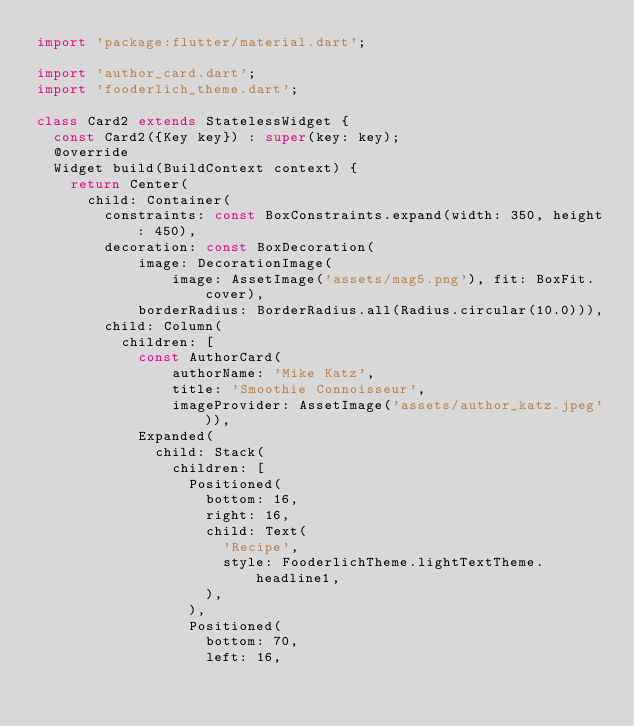<code> <loc_0><loc_0><loc_500><loc_500><_Dart_>import 'package:flutter/material.dart';

import 'author_card.dart';
import 'fooderlich_theme.dart';

class Card2 extends StatelessWidget {
  const Card2({Key key}) : super(key: key);
  @override
  Widget build(BuildContext context) {
    return Center(
      child: Container(
        constraints: const BoxConstraints.expand(width: 350, height: 450),
        decoration: const BoxDecoration(
            image: DecorationImage(
                image: AssetImage('assets/mag5.png'), fit: BoxFit.cover),
            borderRadius: BorderRadius.all(Radius.circular(10.0))),
        child: Column(
          children: [
            const AuthorCard(
                authorName: 'Mike Katz',
                title: 'Smoothie Connoisseur',
                imageProvider: AssetImage('assets/author_katz.jpeg')),
            Expanded(
              child: Stack(
                children: [
                  Positioned(
                    bottom: 16,
                    right: 16,
                    child: Text(
                      'Recipe',
                      style: FooderlichTheme.lightTextTheme.headline1,
                    ),
                  ),
                  Positioned(
                    bottom: 70,
                    left: 16,</code> 